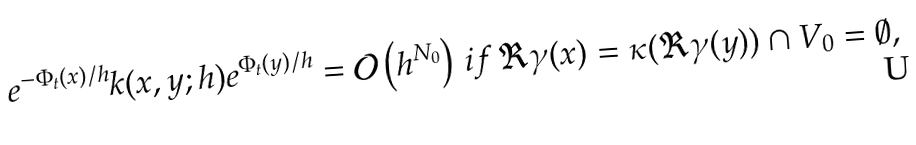Convert formula to latex. <formula><loc_0><loc_0><loc_500><loc_500>e ^ { - \Phi _ { t } ( x ) / h } k ( x , y ; h ) e ^ { \Phi _ { t } ( y ) / h } = { \mathcal { O } } \left ( h ^ { N _ { 0 } } \right ) \, i f \, \Re \gamma ( x ) = \kappa ( \Re \gamma ( y ) ) \cap V _ { 0 } = \emptyset ,</formula> 